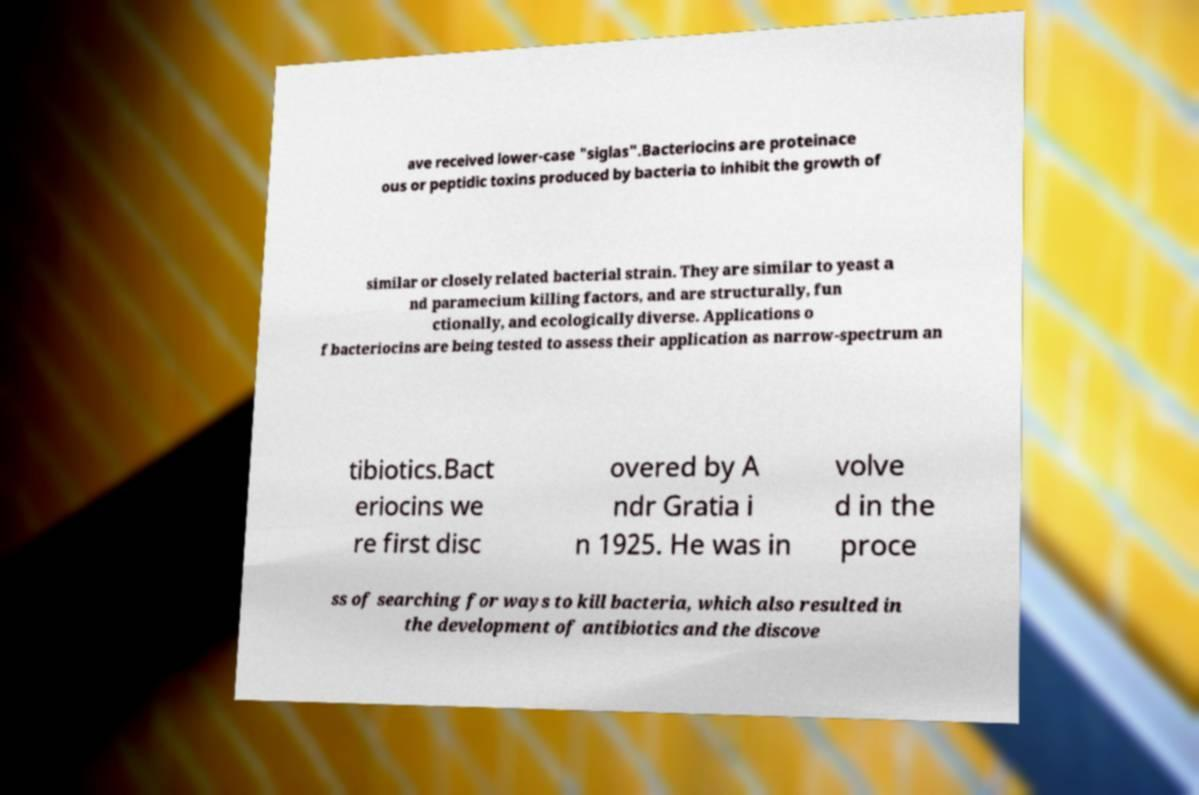What messages or text are displayed in this image? I need them in a readable, typed format. ave received lower-case "siglas".Bacteriocins are proteinace ous or peptidic toxins produced by bacteria to inhibit the growth of similar or closely related bacterial strain. They are similar to yeast a nd paramecium killing factors, and are structurally, fun ctionally, and ecologically diverse. Applications o f bacteriocins are being tested to assess their application as narrow-spectrum an tibiotics.Bact eriocins we re first disc overed by A ndr Gratia i n 1925. He was in volve d in the proce ss of searching for ways to kill bacteria, which also resulted in the development of antibiotics and the discove 